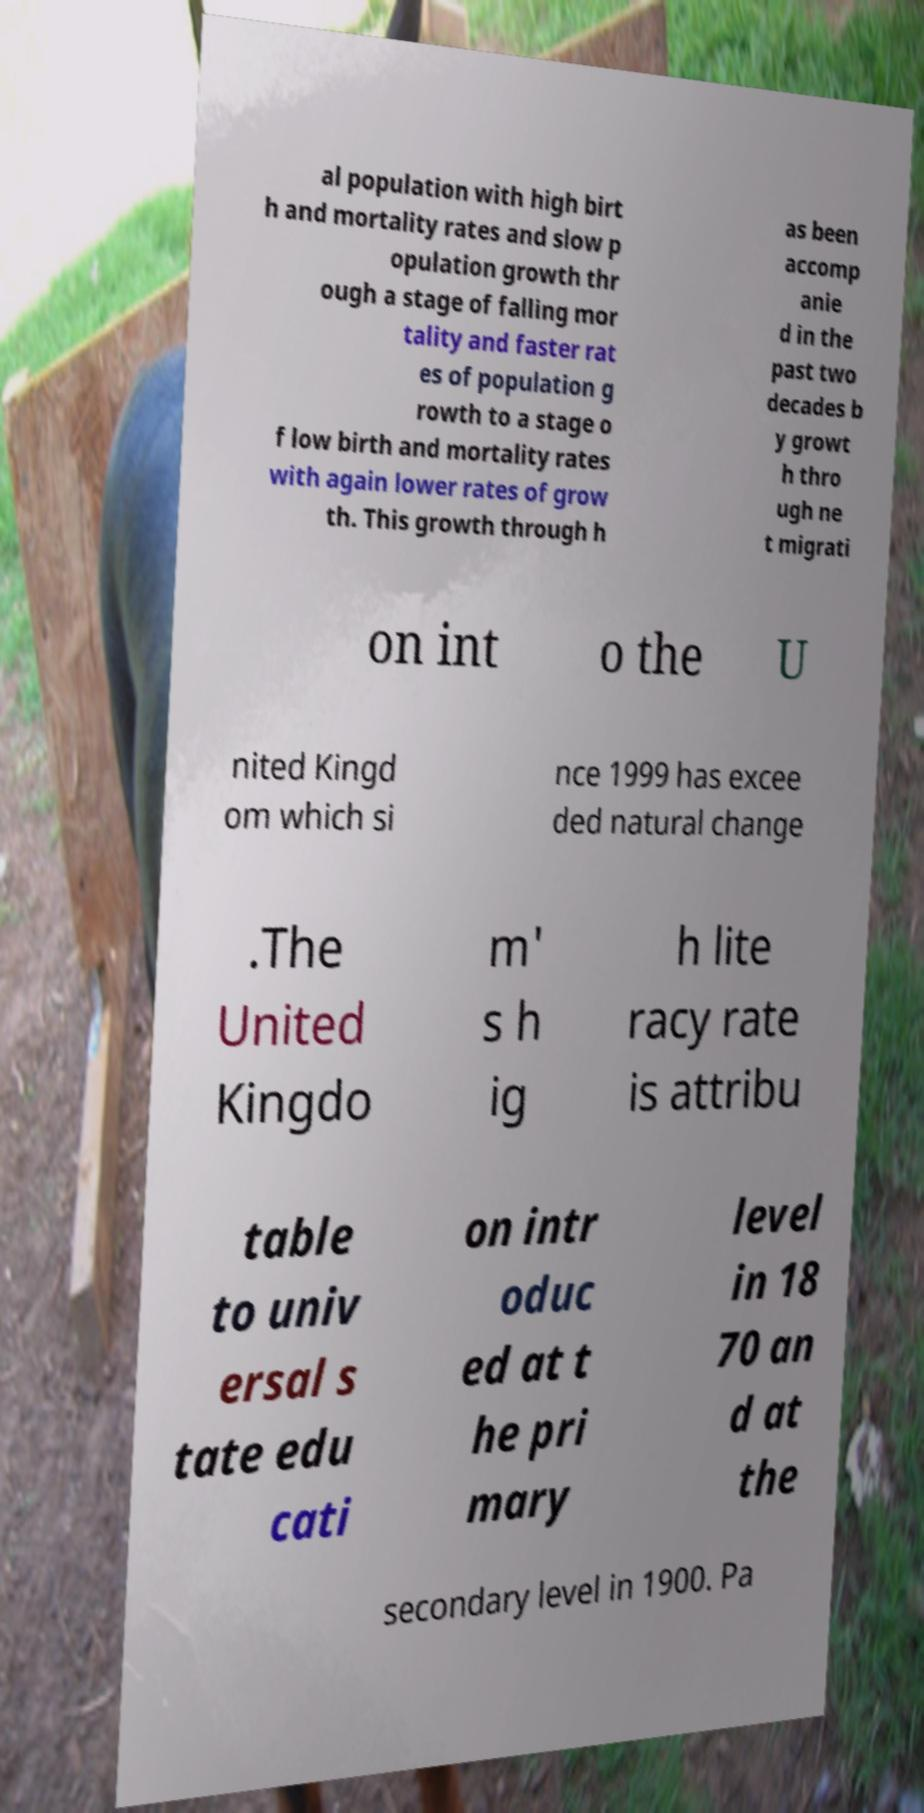Can you accurately transcribe the text from the provided image for me? al population with high birt h and mortality rates and slow p opulation growth thr ough a stage of falling mor tality and faster rat es of population g rowth to a stage o f low birth and mortality rates with again lower rates of grow th. This growth through h as been accomp anie d in the past two decades b y growt h thro ugh ne t migrati on int o the U nited Kingd om which si nce 1999 has excee ded natural change .The United Kingdo m' s h ig h lite racy rate is attribu table to univ ersal s tate edu cati on intr oduc ed at t he pri mary level in 18 70 an d at the secondary level in 1900. Pa 